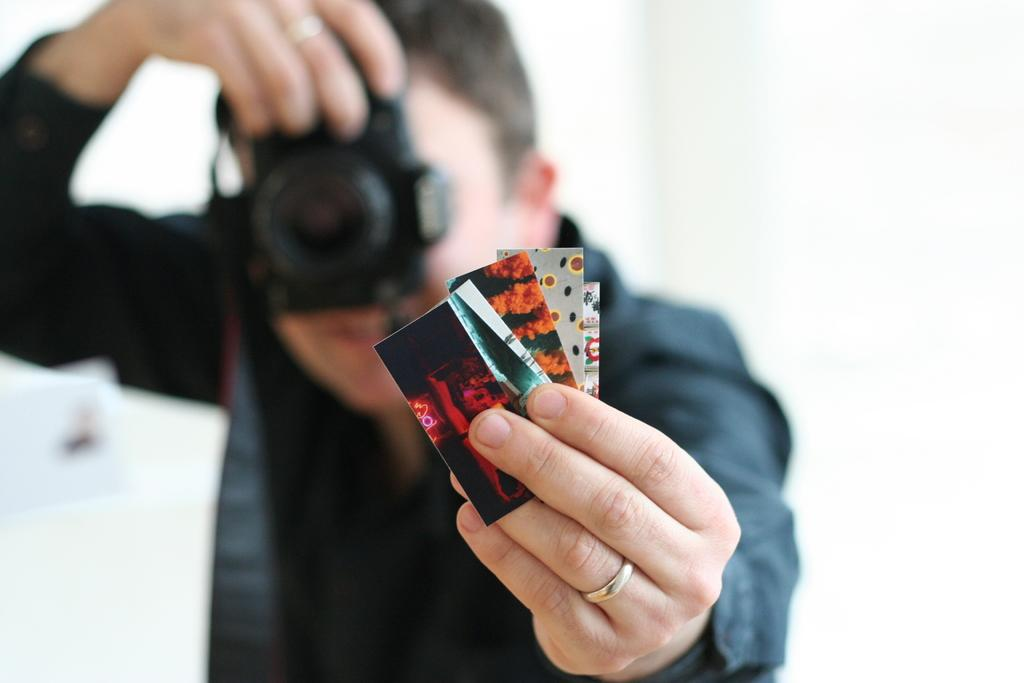What is the main subject of the image? There is a person in the image. What is the person doing with the cards? The person is holding different cards and taking a photo of them. What type of creature can be seen holding the scissors in the image? There is no creature present in the image, nor are there any scissors. 